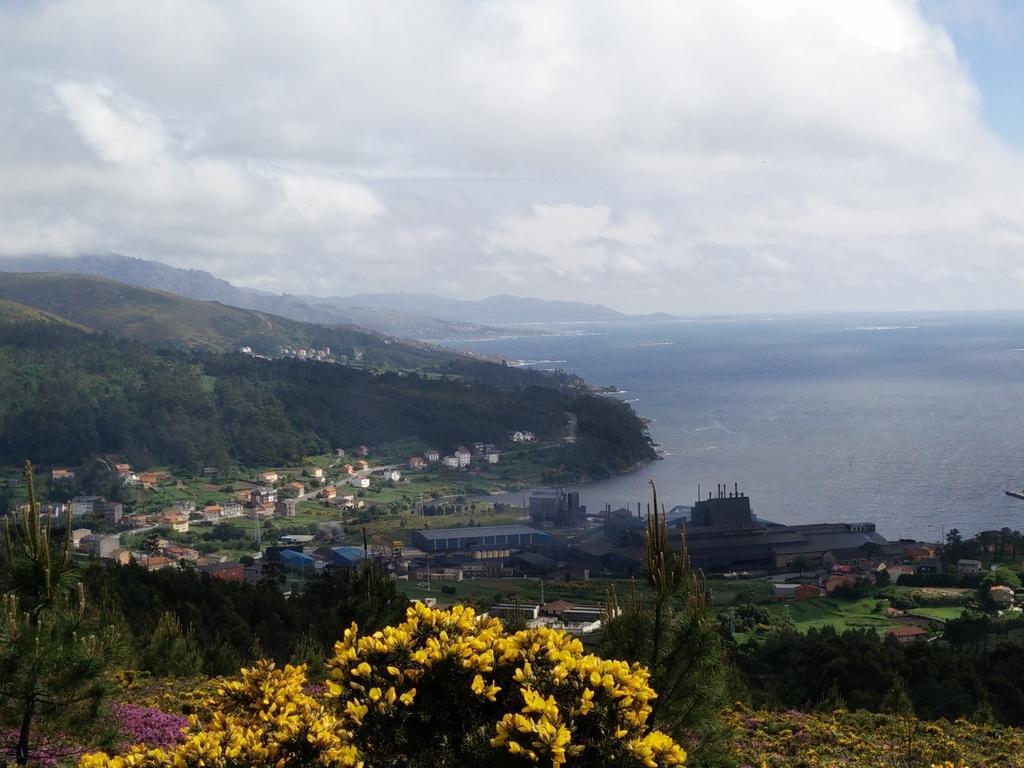Describe this image in one or two sentences. In this image we can see many hills, houses, buildings, trees and plants. There are flowers to the plants. There is a grassy land in the image. There is a blue and cloudy sky in the image. There is a sea in the image. 